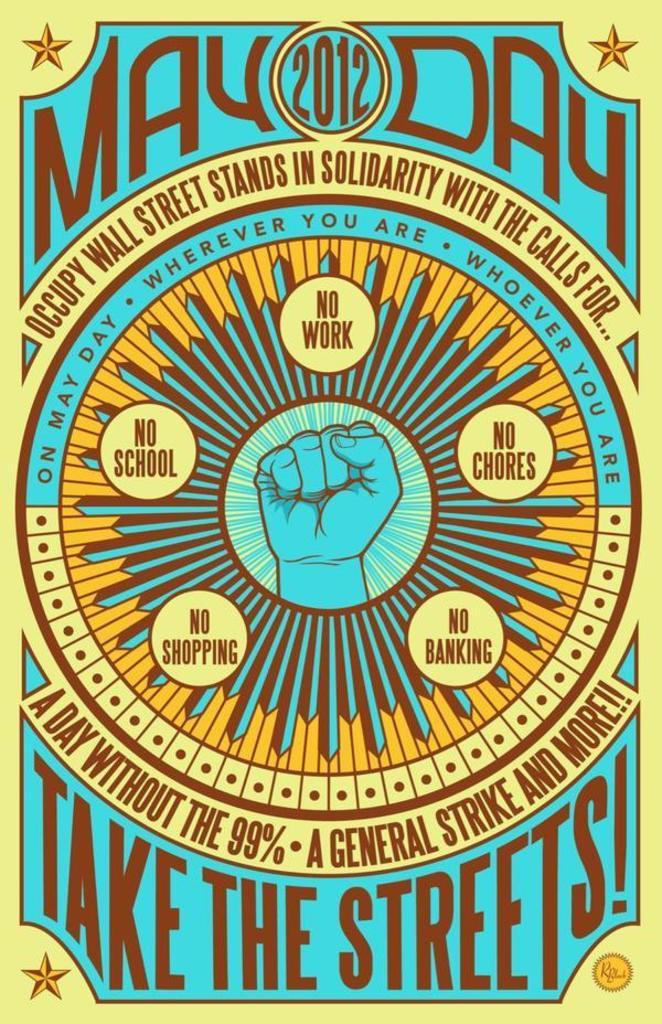Provide a one-sentence caption for the provided image. Yellow and brown poster that says May Day 2012. 